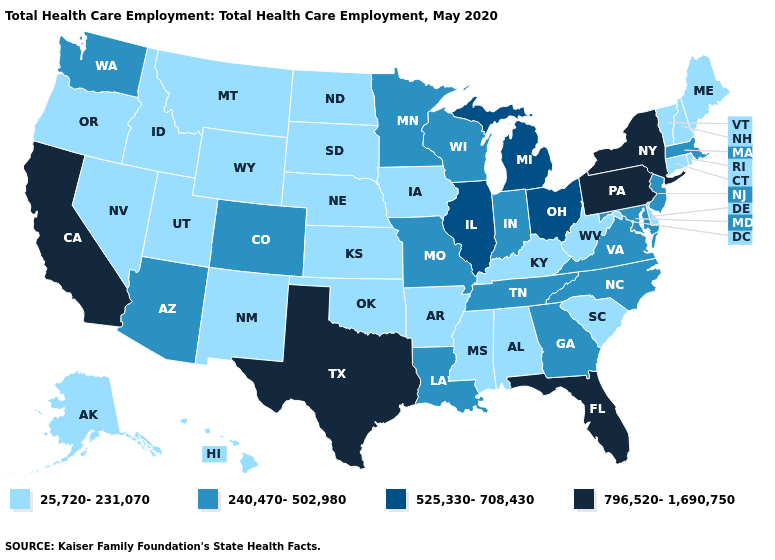How many symbols are there in the legend?
Concise answer only. 4. What is the value of South Dakota?
Answer briefly. 25,720-231,070. What is the lowest value in states that border Massachusetts?
Be succinct. 25,720-231,070. What is the value of Wyoming?
Keep it brief. 25,720-231,070. Does the map have missing data?
Keep it brief. No. What is the value of Washington?
Concise answer only. 240,470-502,980. Which states have the lowest value in the USA?
Concise answer only. Alabama, Alaska, Arkansas, Connecticut, Delaware, Hawaii, Idaho, Iowa, Kansas, Kentucky, Maine, Mississippi, Montana, Nebraska, Nevada, New Hampshire, New Mexico, North Dakota, Oklahoma, Oregon, Rhode Island, South Carolina, South Dakota, Utah, Vermont, West Virginia, Wyoming. What is the highest value in states that border Tennessee?
Concise answer only. 240,470-502,980. Is the legend a continuous bar?
Keep it brief. No. Name the states that have a value in the range 796,520-1,690,750?
Short answer required. California, Florida, New York, Pennsylvania, Texas. What is the lowest value in the USA?
Short answer required. 25,720-231,070. What is the value of Florida?
Write a very short answer. 796,520-1,690,750. Does Rhode Island have the lowest value in the Northeast?
Answer briefly. Yes. Does Arizona have a higher value than California?
Concise answer only. No. Name the states that have a value in the range 525,330-708,430?
Quick response, please. Illinois, Michigan, Ohio. 